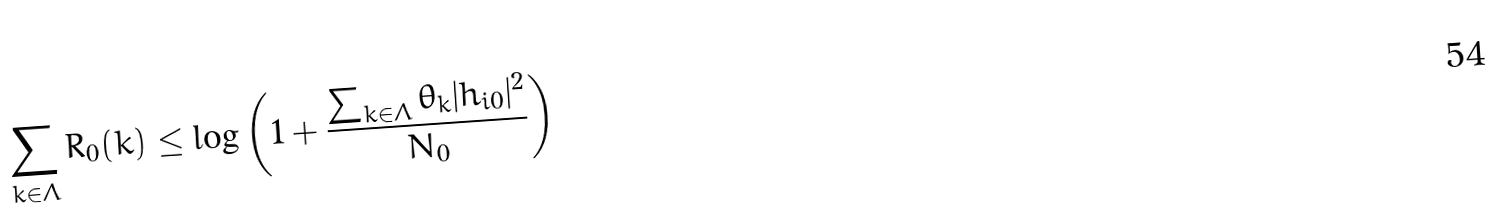<formula> <loc_0><loc_0><loc_500><loc_500>\sum _ { k \in \Lambda } R _ { 0 } ( k ) \leq \log \left ( 1 + \frac { \sum _ { k \in \Lambda } \theta _ { k } | h _ { i 0 } | ^ { 2 } } { N _ { 0 } } \right )</formula> 